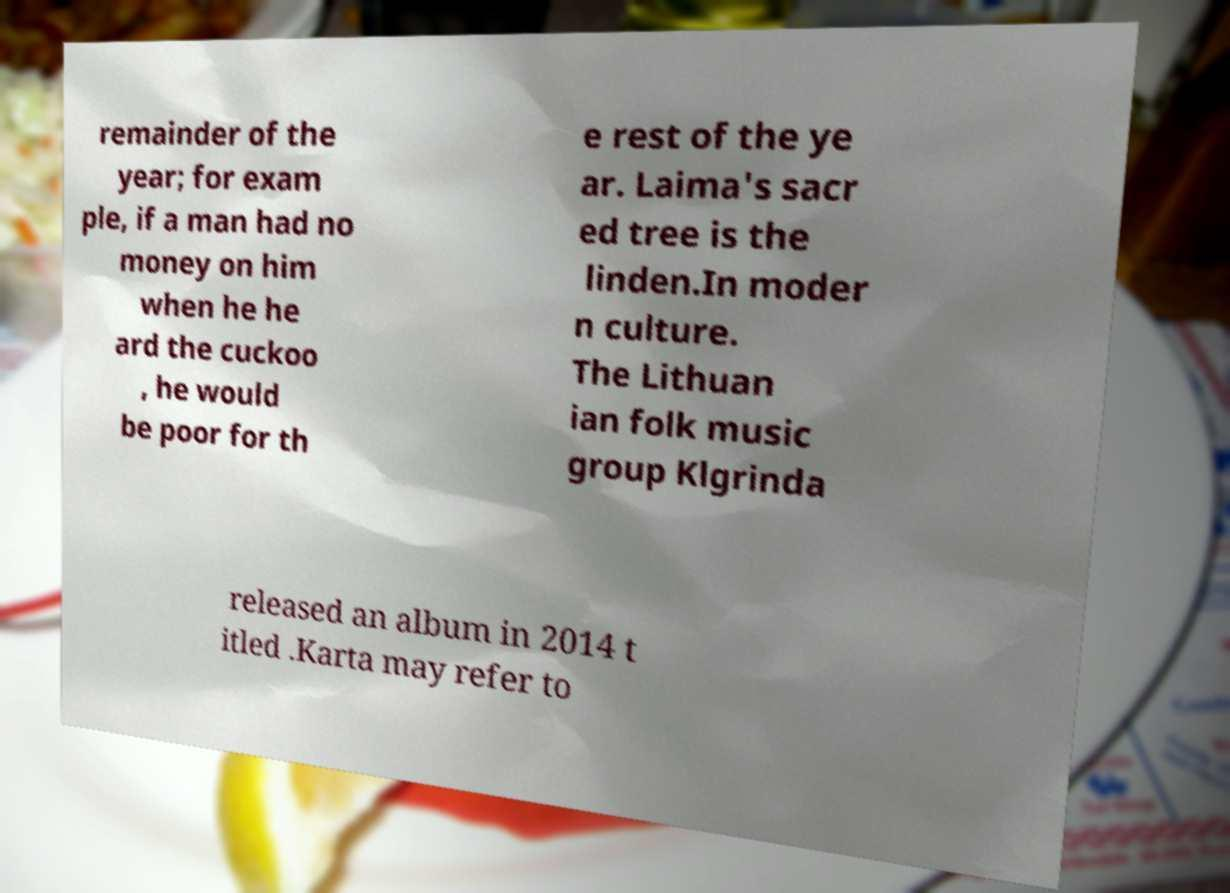Could you assist in decoding the text presented in this image and type it out clearly? remainder of the year; for exam ple, if a man had no money on him when he he ard the cuckoo , he would be poor for th e rest of the ye ar. Laima's sacr ed tree is the linden.In moder n culture. The Lithuan ian folk music group Klgrinda released an album in 2014 t itled .Karta may refer to 